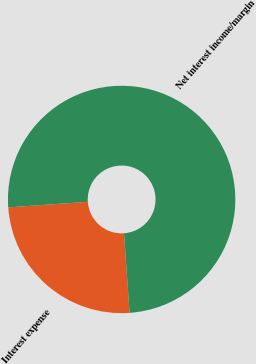Convert chart. <chart><loc_0><loc_0><loc_500><loc_500><pie_chart><fcel>Interest expense<fcel>Net interest income/margin<nl><fcel>25.0%<fcel>75.0%<nl></chart> 